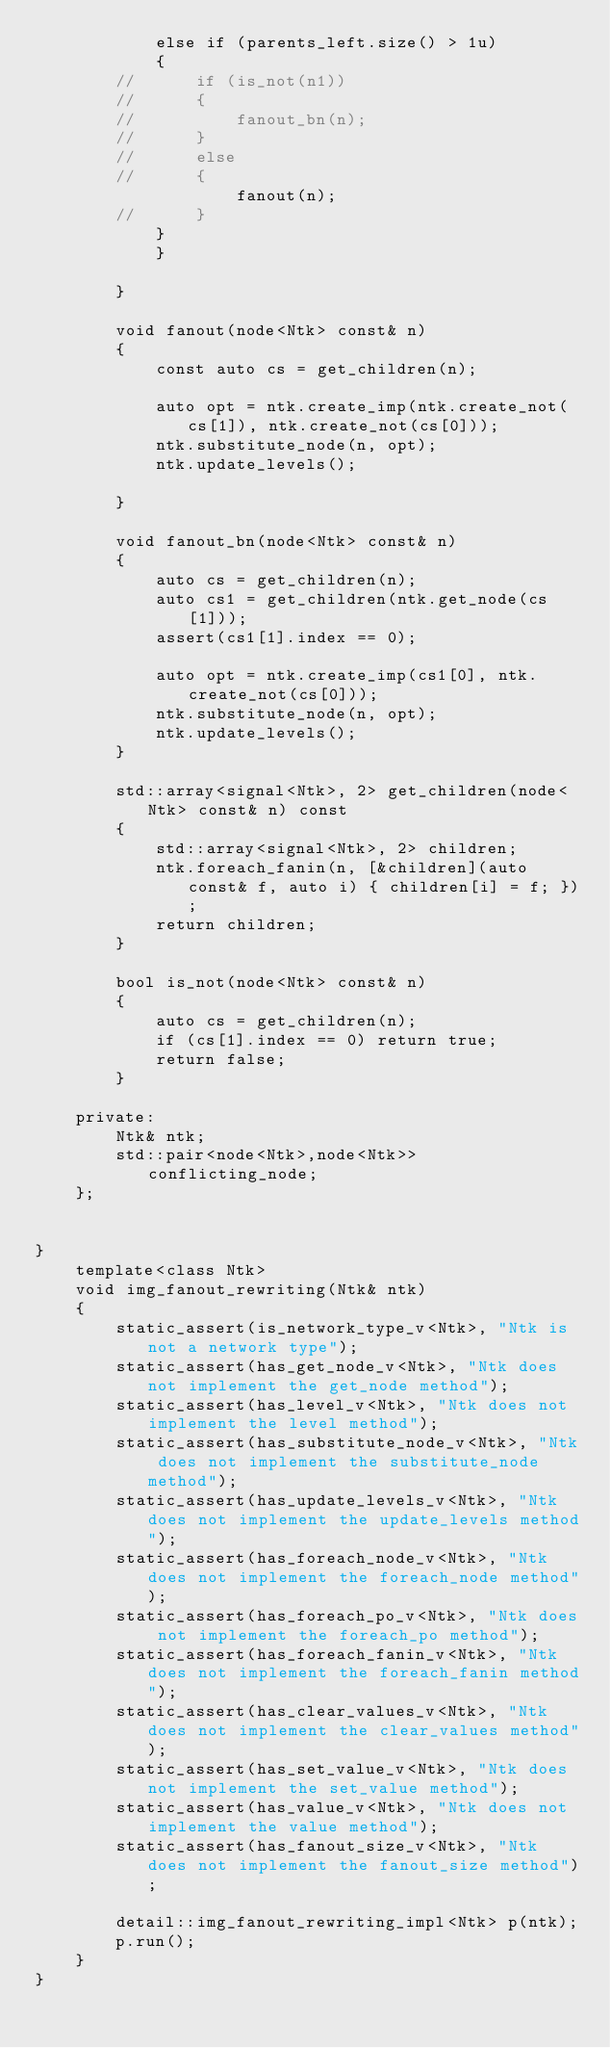Convert code to text. <code><loc_0><loc_0><loc_500><loc_500><_C++_>			else if (parents_left.size() > 1u)
			{
		//		if (is_not(n1))
		//		{
		//			fanout_bn(n);
		//		}
		//		else
		//		{
					fanout(n);
		//		}
			}
            }

		}

		void fanout(node<Ntk> const& n)
		{
			const auto cs = get_children(n);

			auto opt = ntk.create_imp(ntk.create_not(cs[1]), ntk.create_not(cs[0]));
			ntk.substitute_node(n, opt);
			ntk.update_levels();

		}

		void fanout_bn(node<Ntk> const& n)
		{
			auto cs = get_children(n);
			auto cs1 = get_children(ntk.get_node(cs[1]));
			assert(cs1[1].index == 0);

			auto opt = ntk.create_imp(cs1[0], ntk.create_not(cs[0]));
			ntk.substitute_node(n, opt);
			ntk.update_levels();
		}

		std::array<signal<Ntk>, 2> get_children(node<Ntk> const& n) const
		{
			std::array<signal<Ntk>, 2> children;
			ntk.foreach_fanin(n, [&children](auto const& f, auto i) { children[i] = f; });
			return children;
		}

		bool is_not(node<Ntk> const& n)
		{
			auto cs = get_children(n);
			if (cs[1].index == 0) return true;
			return false;
		}

	private:
		Ntk& ntk;
		std::pair<node<Ntk>,node<Ntk>> conflicting_node;
	};


}
	template<class Ntk>
	void img_fanout_rewriting(Ntk& ntk)
	{
		static_assert(is_network_type_v<Ntk>, "Ntk is not a network type");
		static_assert(has_get_node_v<Ntk>, "Ntk does not implement the get_node method");
		static_assert(has_level_v<Ntk>, "Ntk does not implement the level method");
		static_assert(has_substitute_node_v<Ntk>, "Ntk does not implement the substitute_node method");
		static_assert(has_update_levels_v<Ntk>, "Ntk does not implement the update_levels method");
		static_assert(has_foreach_node_v<Ntk>, "Ntk does not implement the foreach_node method");
		static_assert(has_foreach_po_v<Ntk>, "Ntk does not implement the foreach_po method");
		static_assert(has_foreach_fanin_v<Ntk>, "Ntk does not implement the foreach_fanin method");
		static_assert(has_clear_values_v<Ntk>, "Ntk does not implement the clear_values method");
		static_assert(has_set_value_v<Ntk>, "Ntk does not implement the set_value method");
		static_assert(has_value_v<Ntk>, "Ntk does not implement the value method");
		static_assert(has_fanout_size_v<Ntk>, "Ntk does not implement the fanout_size method");

		detail::img_fanout_rewriting_impl<Ntk> p(ntk);
		p.run();
	}
}

</code> 